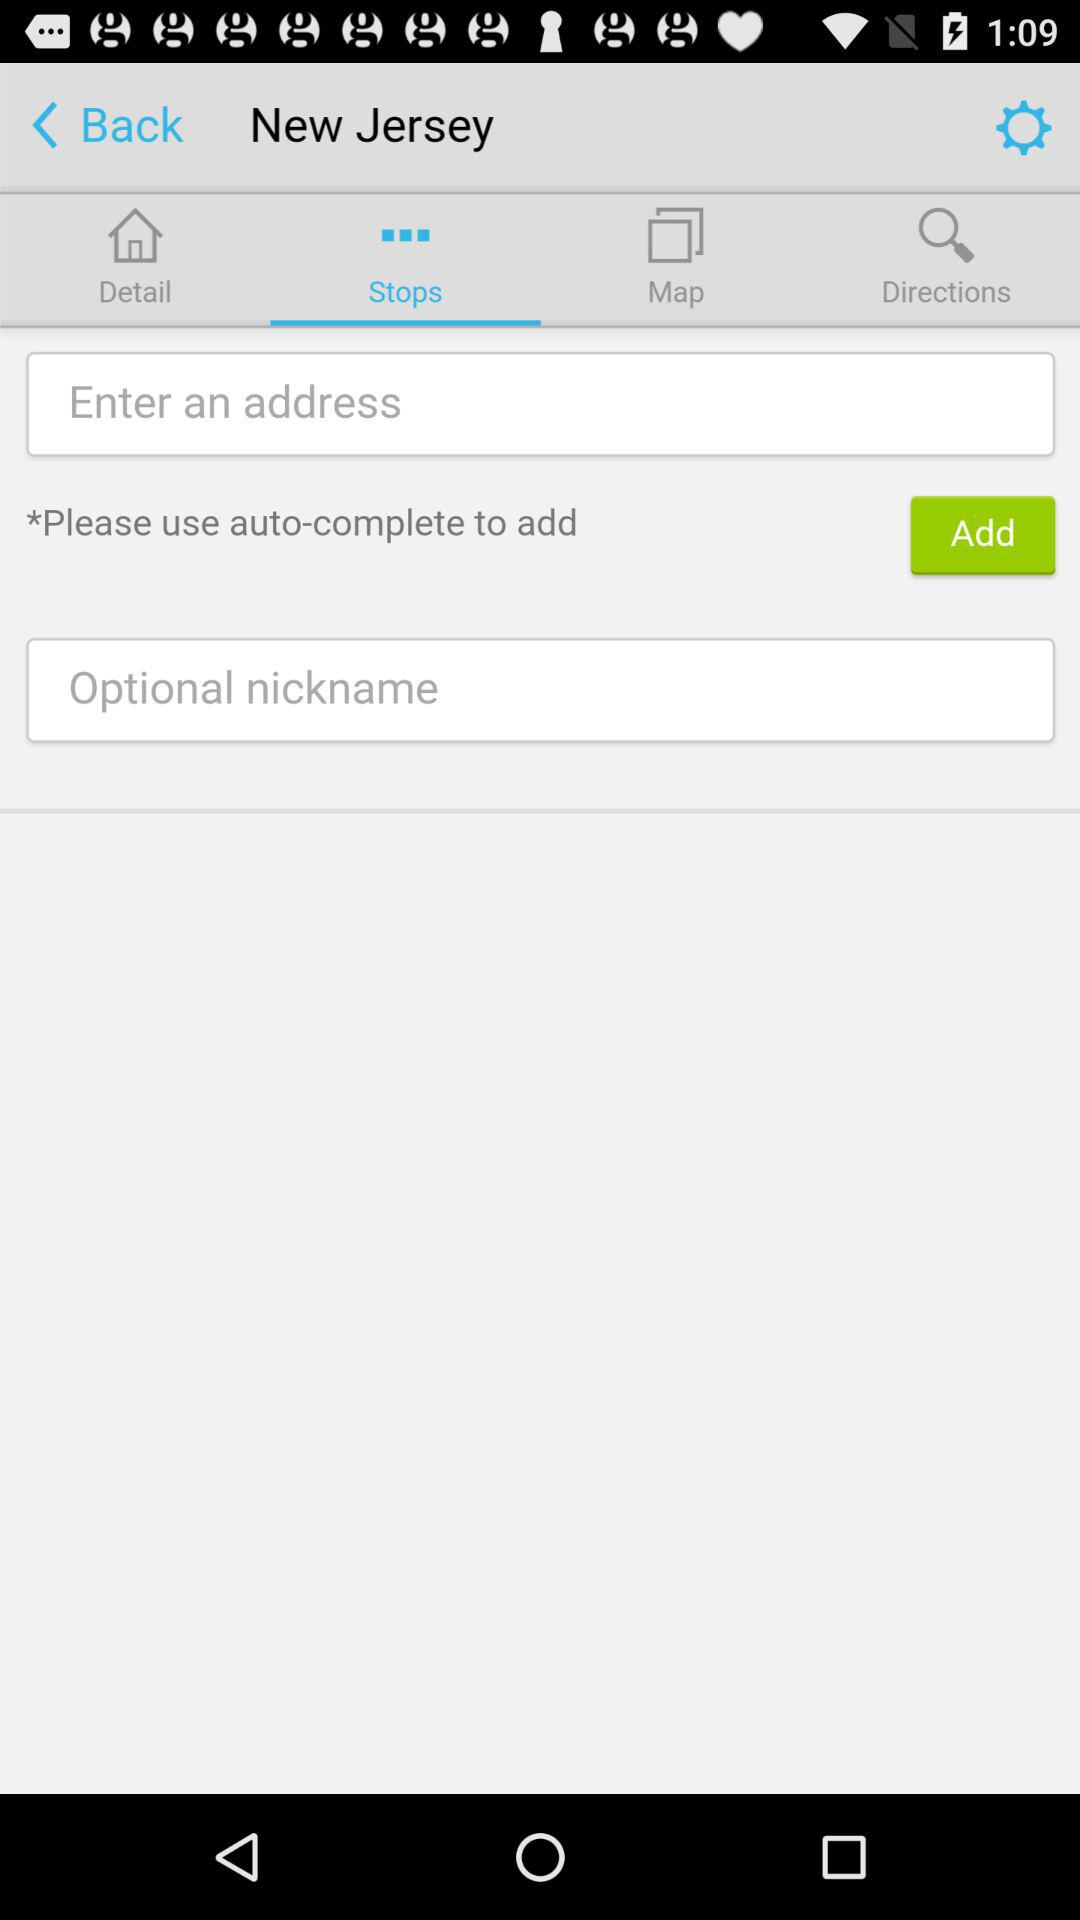On which tab of the application are we? The tab you are on is "Stops". 